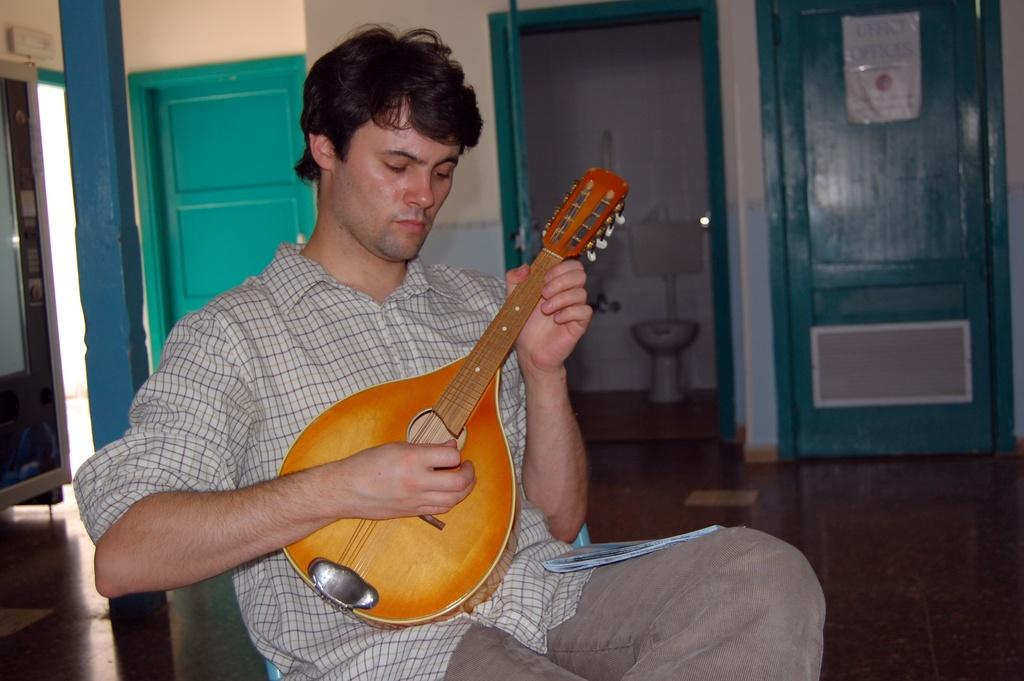What is the person in the image wearing? The person is wearing a check shirt and trousers. What is the person doing in the image? The person is playing a musical instrument. What can be seen in the background of the image? There is a door, a pillar, a bathroom, and a wall in the background of the image. Are there any visible locks on the bathroom door in the image? There is no mention of locks or any specific details about the bathroom door in the image. 